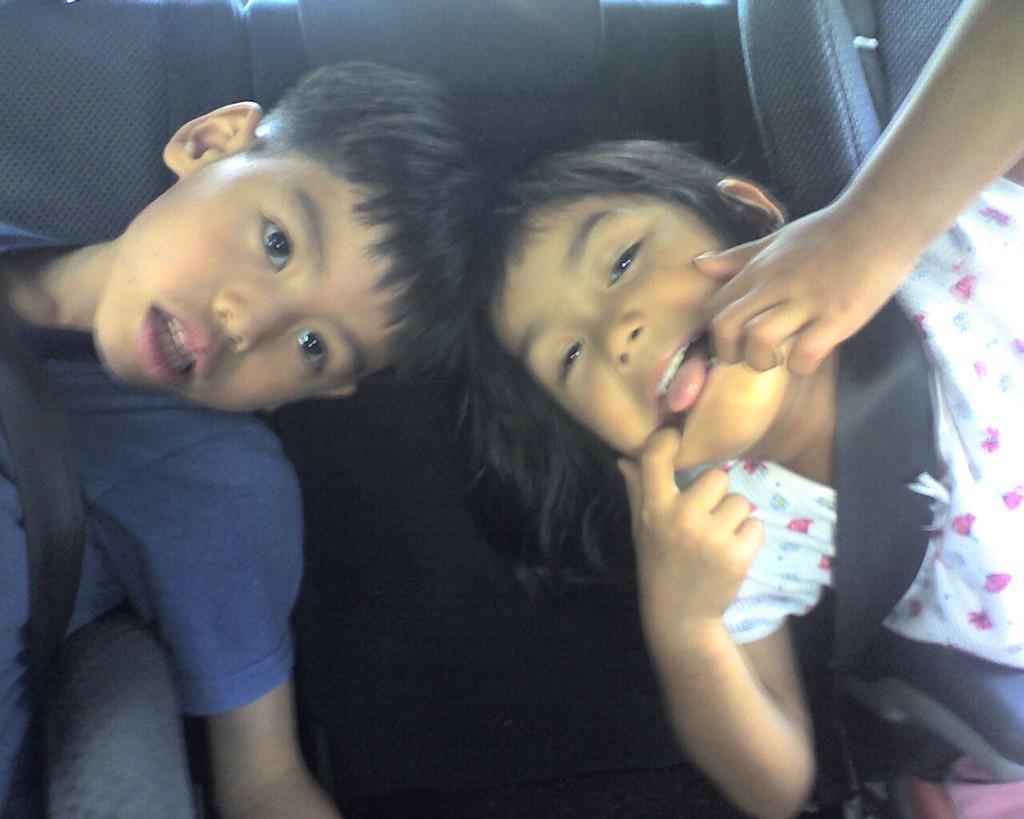Could you give a brief overview of what you see in this image? In this image I can see a boy wearing blue t shirt and a girl wearing white and pink colored dress are siting on chairs. I can see the black colored chairs inside the vehicle. 